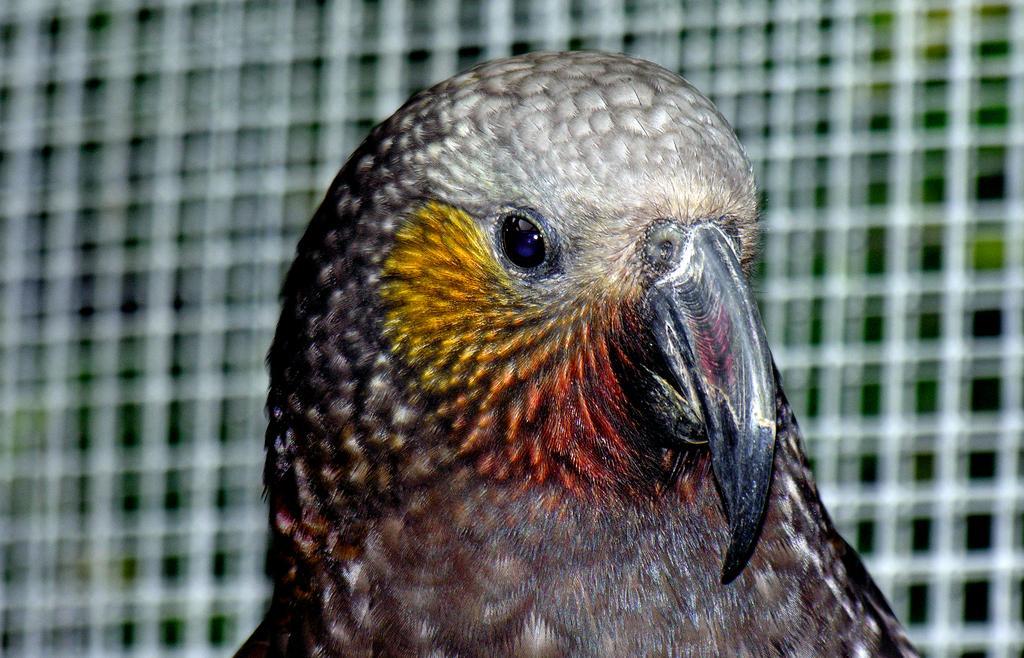Can you describe this image briefly? In this image I can see a bird. The background of the image is blurred. 